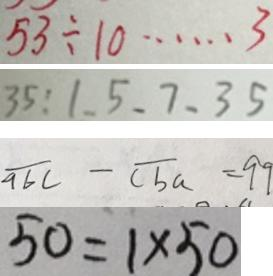Convert formula to latex. <formula><loc_0><loc_0><loc_500><loc_500>5 3 \div 1 0 \cdots 3 
 3 5 : 1 . 5 . 7 . 3 5 
 \overline { a b c } - \overline { c b a } = 9 9 
 5 0 = 1 \times 5 0</formula> 